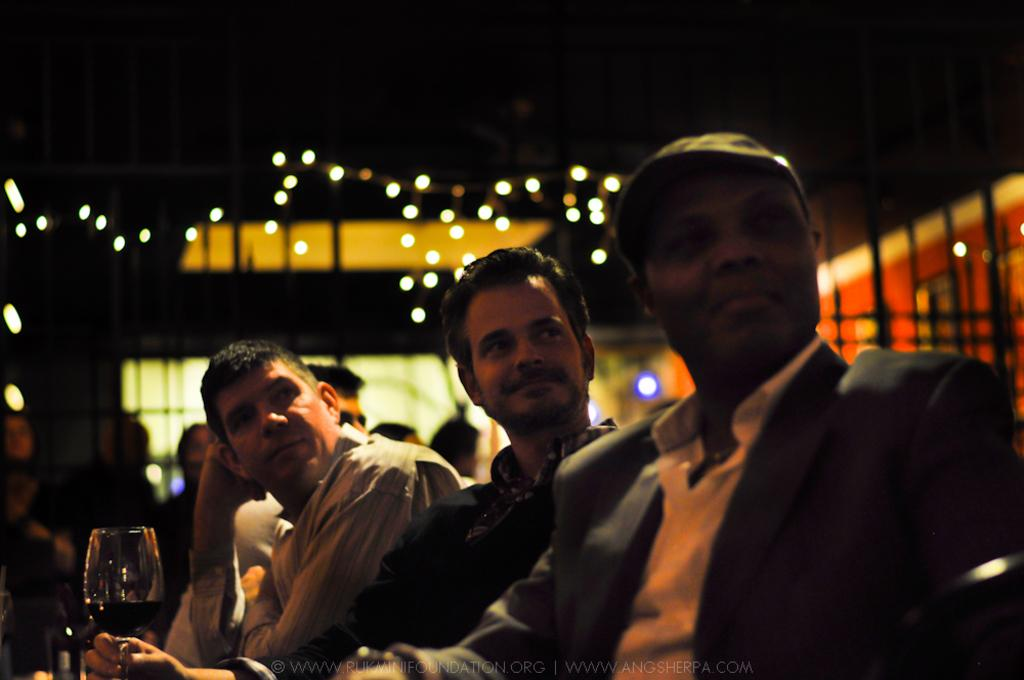What are the persons in the image doing? The persons in the image are sitting. What beverage can be seen in the image? There is a glass of wine in the image. Can you describe the people in the background of the image? There are people in the background of the image. What can be seen illuminated in the image? There are lights visible in the image. How would you describe the clarity of the background in the image? The background of the image appears blurry. What type of parcel is being delivered to the ladybug in the image? There is no ladybug or parcel present in the image. 